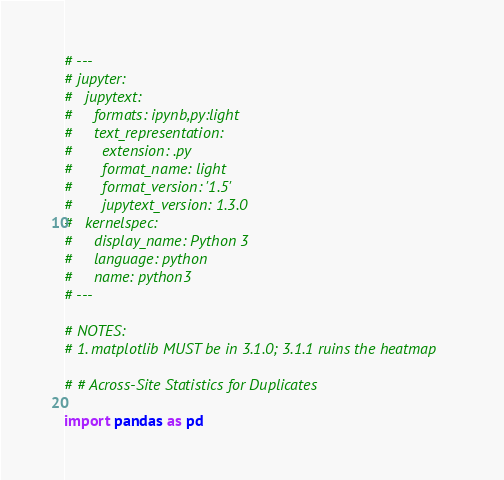<code> <loc_0><loc_0><loc_500><loc_500><_Python_># ---
# jupyter:
#   jupytext:
#     formats: ipynb,py:light
#     text_representation:
#       extension: .py
#       format_name: light
#       format_version: '1.5'
#       jupytext_version: 1.3.0
#   kernelspec:
#     display_name: Python 3
#     language: python
#     name: python3
# ---

# NOTES:
# 1. matplotlib MUST be in 3.1.0; 3.1.1 ruins the heatmap

# # Across-Site Statistics for Duplicates

import pandas as pd</code> 